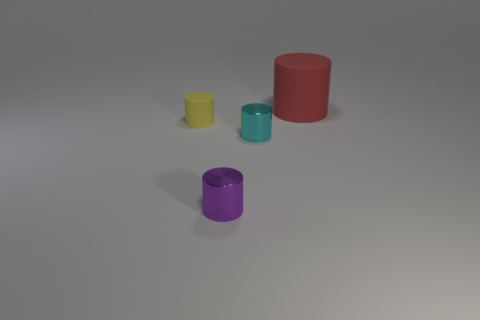Add 1 red cylinders. How many objects exist? 5 Subtract all large things. Subtract all yellow rubber things. How many objects are left? 2 Add 1 yellow matte cylinders. How many yellow matte cylinders are left? 2 Add 4 blue shiny objects. How many blue shiny objects exist? 4 Subtract 0 brown balls. How many objects are left? 4 